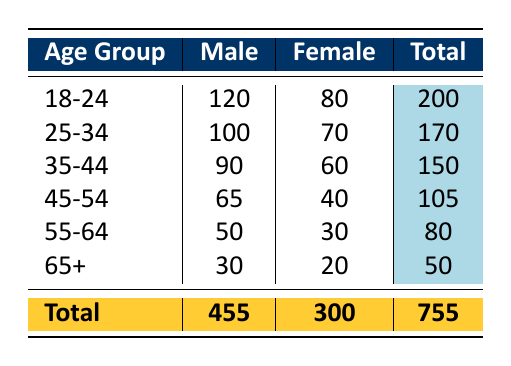What is the total attendance of male fans aged 25-34? According to the table, the attendance of male fans in the age group 25-34 is listed as 100.
Answer: 100 What is the total number of female attendees aged 45-54? The table shows the count of female attendees in the age group 45-54 as 40.
Answer: 40 How many more male attendees are there in the age group 18-24 than in the age group 65+? The number of male attendees in the age group 18-24 is 120 and in the age group 65+ is 30. The difference is 120 - 30 = 90.
Answer: 90 What percentage of the total attendance does the age group 35-44 represent? The total attendance is 755. For the age group 35-44, the total is 150 (90 male and 60 female). The percentage is (150 / 755) * 100 ≈ 19.87%.
Answer: 19.87 Is it true that the attendance for females is higher than for males in the age group 55-64? From the table, the attendance for females is 30 and for males is 50. Therefore, it is false that female attendance is higher than male in this age group.
Answer: No What is the total number of attendees for all age groups? By summing the total attendance for all age groups: 200 + 170 + 150 + 105 + 80 + 50 = 755.
Answer: 755 How many attendees are there in the age group 18-24 across both genders combined? The total for the age group 18-24 is 120 (male) + 80 (female) = 200.
Answer: 200 For which age group is the number of female attendees the lowest? Looking at the table, the age group with the lowest number of female attendees is 65+, with only 20 attendees.
Answer: 65+ How many male attendees are there in total across all age groups? The total male attendees are: 120 + 100 + 90 + 65 + 50 + 30 = 455.
Answer: 455 